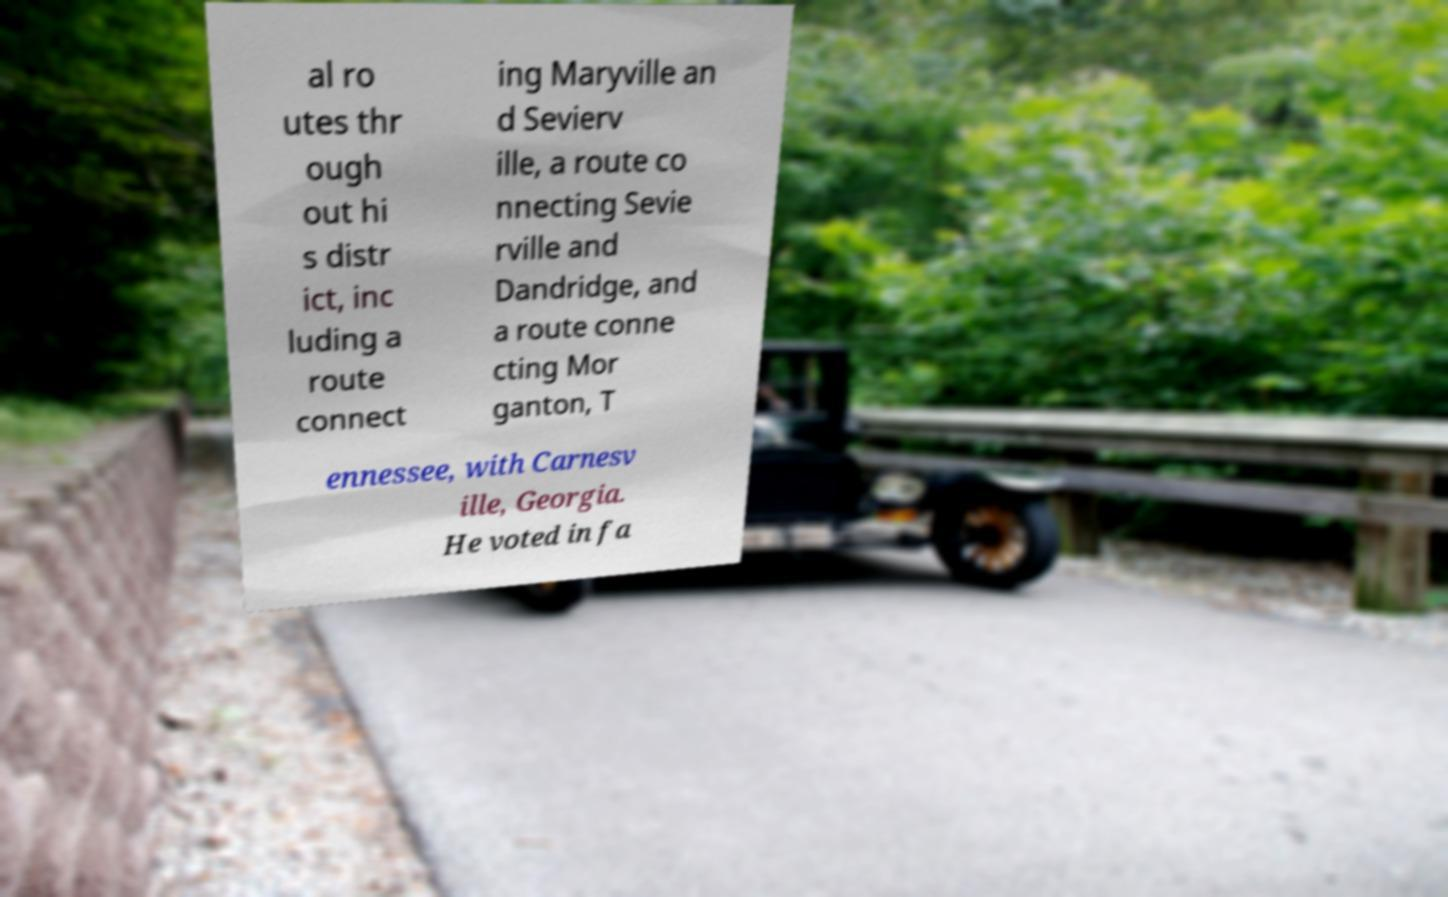Please read and relay the text visible in this image. What does it say? al ro utes thr ough out hi s distr ict, inc luding a route connect ing Maryville an d Sevierv ille, a route co nnecting Sevie rville and Dandridge, and a route conne cting Mor ganton, T ennessee, with Carnesv ille, Georgia. He voted in fa 